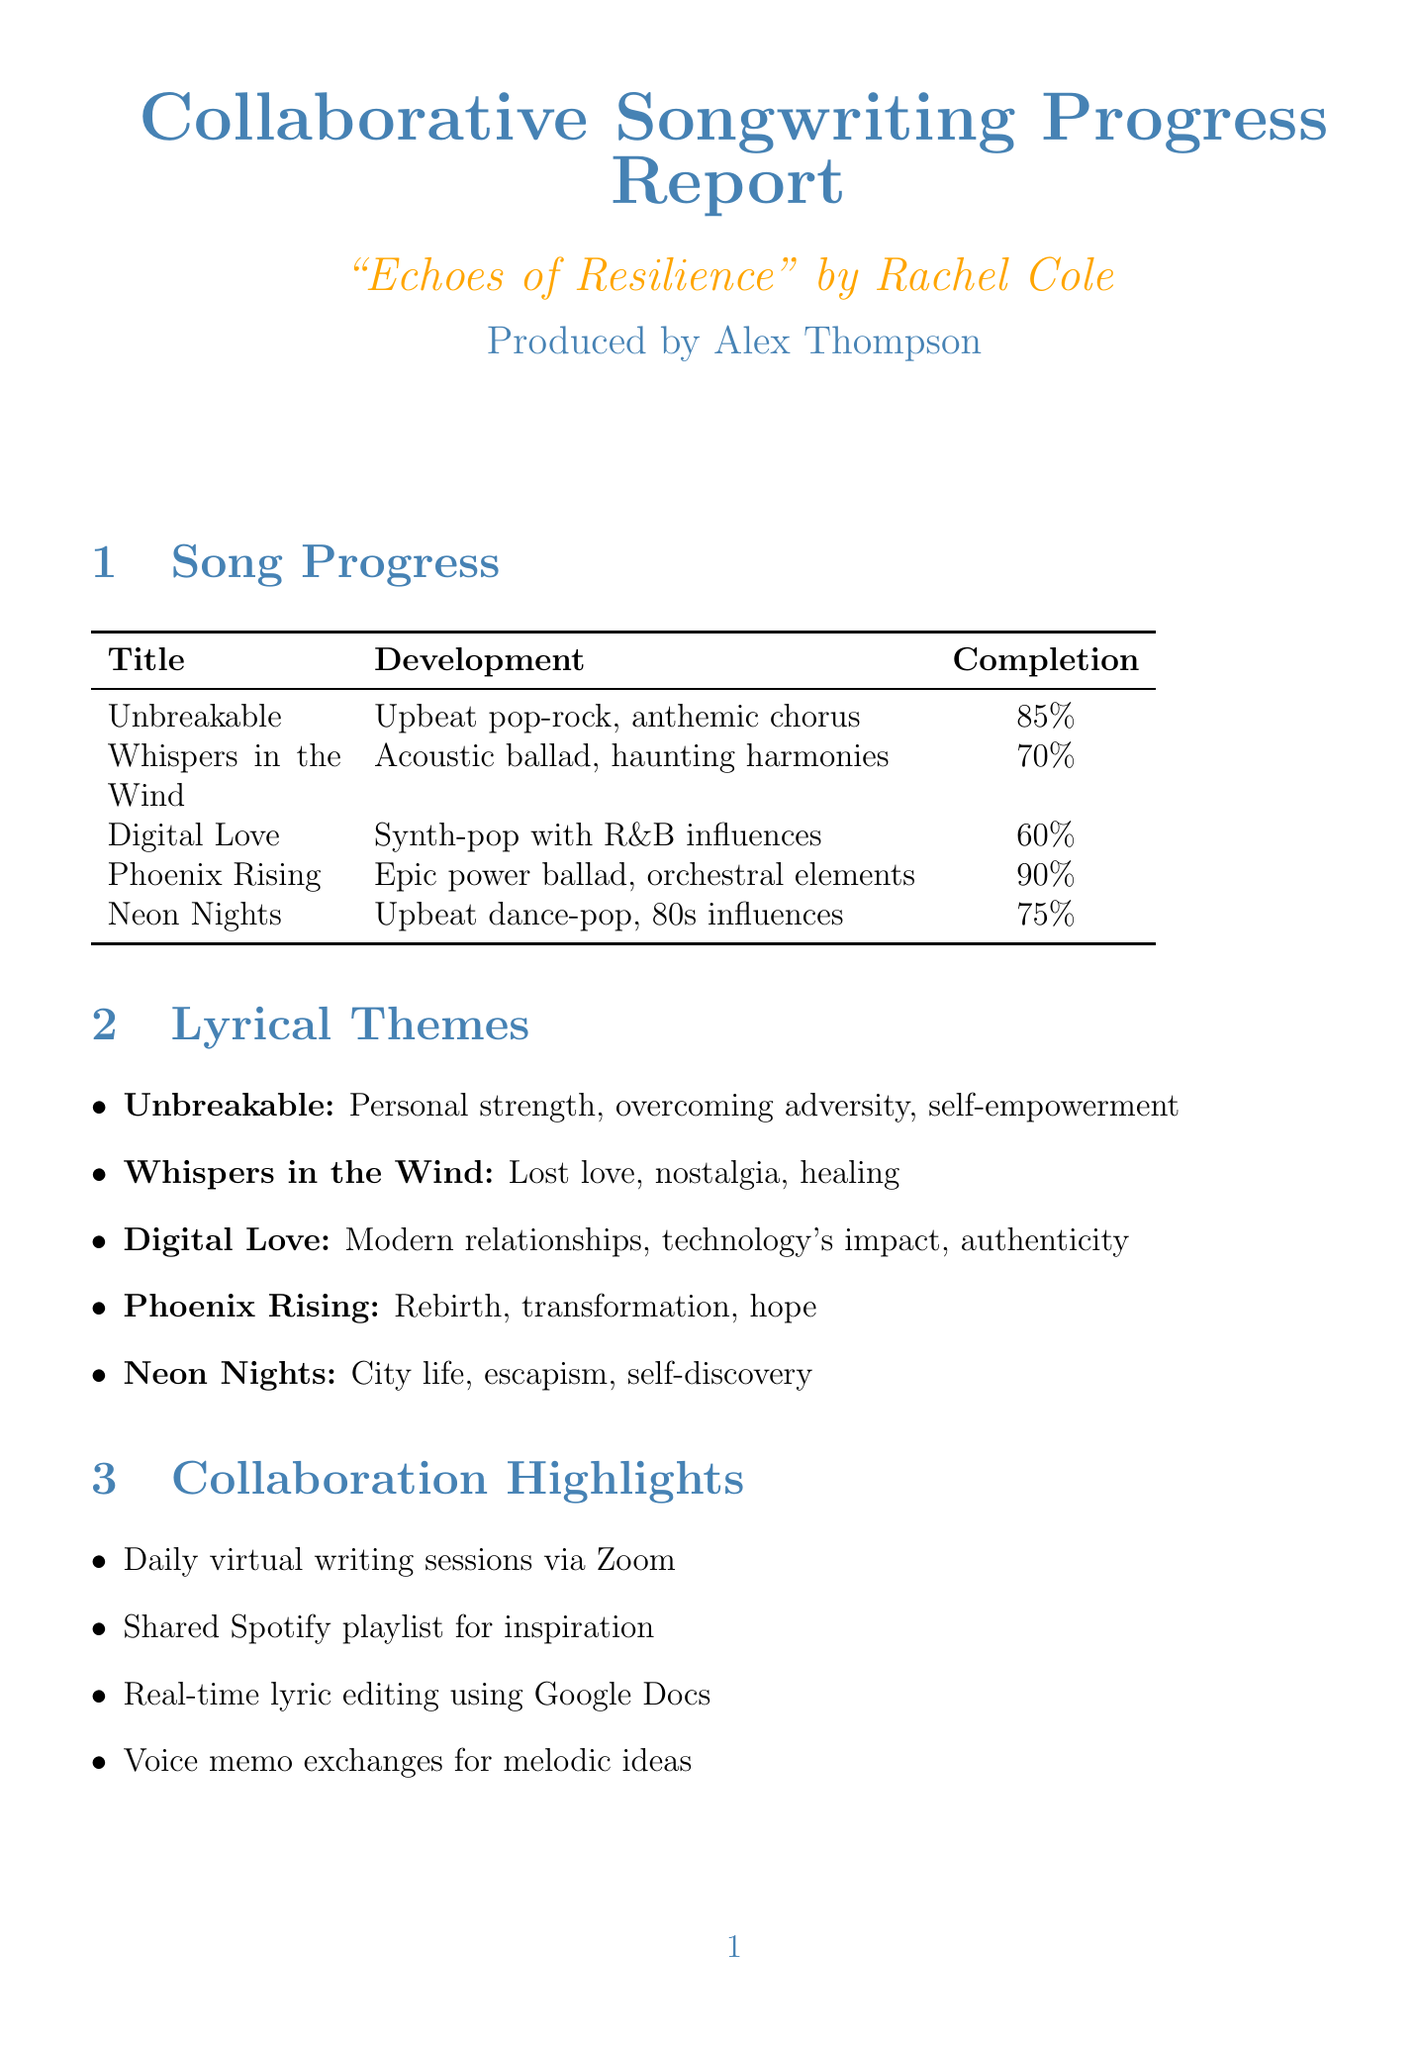What is the title of the album? The title of the album is clearly stated at the beginning of the document.
Answer: Echoes of Resilience Who is the artist of the album? The document specifies the artist related to the album.
Answer: Rachel Cole What is the completion percentage of the song "Digital Love"? The completion percentage for "Digital Love" is noted in the song progress section.
Answer: 60% What are the lyrical themes of the song "Unbreakable"? The lyrical themes are listed under each song in the document.
Answer: Personal strength, overcoming adversity, self-empowerment What is one of the production challenges mentioned in the report? The document lists challenges faced during production.
Answer: Remote recording due to COVID-19 restrictions How many songs are there in total? The number of songs can be calculated from the songwriting progress section of the report.
Answer: 5 What is the target release date of the album? The target release date is explicitly stated in the album details section.
Answer: September 15, 2023 What is one of the next steps in the production process? The next steps are outlined in a dedicated section of the document.
Answer: Finalize lyrics for remaining songs How is the collaboration primarily conducted? The collaboration highlights section describes how the collaboration is taking place.
Answer: Daily virtual writing sessions using Zoom 